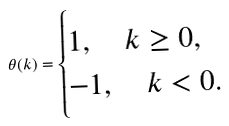Convert formula to latex. <formula><loc_0><loc_0><loc_500><loc_500>\theta ( k ) = \begin{cases} 1 , \quad k \geq 0 , \\ - 1 , \quad k < 0 . \end{cases}</formula> 